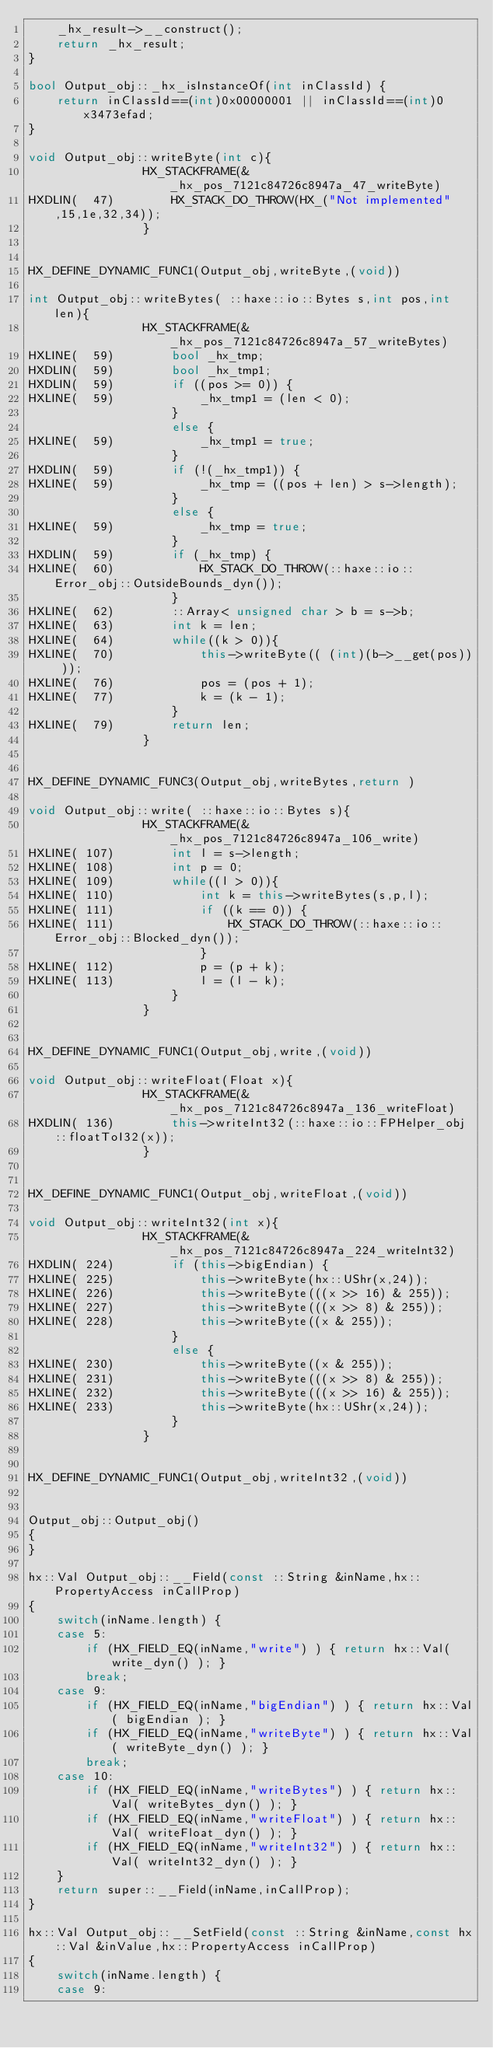Convert code to text. <code><loc_0><loc_0><loc_500><loc_500><_C++_>	_hx_result->__construct();
	return _hx_result;
}

bool Output_obj::_hx_isInstanceOf(int inClassId) {
	return inClassId==(int)0x00000001 || inClassId==(int)0x3473efad;
}

void Output_obj::writeByte(int c){
            	HX_STACKFRAME(&_hx_pos_7121c84726c8947a_47_writeByte)
HXDLIN(  47)		HX_STACK_DO_THROW(HX_("Not implemented",15,1e,32,34));
            	}


HX_DEFINE_DYNAMIC_FUNC1(Output_obj,writeByte,(void))

int Output_obj::writeBytes( ::haxe::io::Bytes s,int pos,int len){
            	HX_STACKFRAME(&_hx_pos_7121c84726c8947a_57_writeBytes)
HXLINE(  59)		bool _hx_tmp;
HXDLIN(  59)		bool _hx_tmp1;
HXDLIN(  59)		if ((pos >= 0)) {
HXLINE(  59)			_hx_tmp1 = (len < 0);
            		}
            		else {
HXLINE(  59)			_hx_tmp1 = true;
            		}
HXDLIN(  59)		if (!(_hx_tmp1)) {
HXLINE(  59)			_hx_tmp = ((pos + len) > s->length);
            		}
            		else {
HXLINE(  59)			_hx_tmp = true;
            		}
HXDLIN(  59)		if (_hx_tmp) {
HXLINE(  60)			HX_STACK_DO_THROW(::haxe::io::Error_obj::OutsideBounds_dyn());
            		}
HXLINE(  62)		::Array< unsigned char > b = s->b;
HXLINE(  63)		int k = len;
HXLINE(  64)		while((k > 0)){
HXLINE(  70)			this->writeByte(( (int)(b->__get(pos)) ));
HXLINE(  76)			pos = (pos + 1);
HXLINE(  77)			k = (k - 1);
            		}
HXLINE(  79)		return len;
            	}


HX_DEFINE_DYNAMIC_FUNC3(Output_obj,writeBytes,return )

void Output_obj::write( ::haxe::io::Bytes s){
            	HX_STACKFRAME(&_hx_pos_7121c84726c8947a_106_write)
HXLINE( 107)		int l = s->length;
HXLINE( 108)		int p = 0;
HXLINE( 109)		while((l > 0)){
HXLINE( 110)			int k = this->writeBytes(s,p,l);
HXLINE( 111)			if ((k == 0)) {
HXLINE( 111)				HX_STACK_DO_THROW(::haxe::io::Error_obj::Blocked_dyn());
            			}
HXLINE( 112)			p = (p + k);
HXLINE( 113)			l = (l - k);
            		}
            	}


HX_DEFINE_DYNAMIC_FUNC1(Output_obj,write,(void))

void Output_obj::writeFloat(Float x){
            	HX_STACKFRAME(&_hx_pos_7121c84726c8947a_136_writeFloat)
HXDLIN( 136)		this->writeInt32(::haxe::io::FPHelper_obj::floatToI32(x));
            	}


HX_DEFINE_DYNAMIC_FUNC1(Output_obj,writeFloat,(void))

void Output_obj::writeInt32(int x){
            	HX_STACKFRAME(&_hx_pos_7121c84726c8947a_224_writeInt32)
HXDLIN( 224)		if (this->bigEndian) {
HXLINE( 225)			this->writeByte(hx::UShr(x,24));
HXLINE( 226)			this->writeByte(((x >> 16) & 255));
HXLINE( 227)			this->writeByte(((x >> 8) & 255));
HXLINE( 228)			this->writeByte((x & 255));
            		}
            		else {
HXLINE( 230)			this->writeByte((x & 255));
HXLINE( 231)			this->writeByte(((x >> 8) & 255));
HXLINE( 232)			this->writeByte(((x >> 16) & 255));
HXLINE( 233)			this->writeByte(hx::UShr(x,24));
            		}
            	}


HX_DEFINE_DYNAMIC_FUNC1(Output_obj,writeInt32,(void))


Output_obj::Output_obj()
{
}

hx::Val Output_obj::__Field(const ::String &inName,hx::PropertyAccess inCallProp)
{
	switch(inName.length) {
	case 5:
		if (HX_FIELD_EQ(inName,"write") ) { return hx::Val( write_dyn() ); }
		break;
	case 9:
		if (HX_FIELD_EQ(inName,"bigEndian") ) { return hx::Val( bigEndian ); }
		if (HX_FIELD_EQ(inName,"writeByte") ) { return hx::Val( writeByte_dyn() ); }
		break;
	case 10:
		if (HX_FIELD_EQ(inName,"writeBytes") ) { return hx::Val( writeBytes_dyn() ); }
		if (HX_FIELD_EQ(inName,"writeFloat") ) { return hx::Val( writeFloat_dyn() ); }
		if (HX_FIELD_EQ(inName,"writeInt32") ) { return hx::Val( writeInt32_dyn() ); }
	}
	return super::__Field(inName,inCallProp);
}

hx::Val Output_obj::__SetField(const ::String &inName,const hx::Val &inValue,hx::PropertyAccess inCallProp)
{
	switch(inName.length) {
	case 9:</code> 